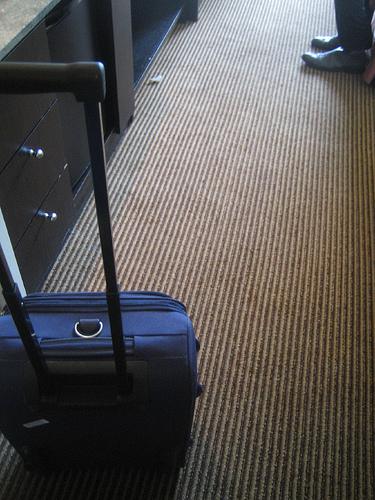Is this person going on a 6 month vacation?
Short answer required. No. Is there a pattern to the carpet?
Concise answer only. Yes. Does this suitcase likely have wheels on it?
Be succinct. Yes. 